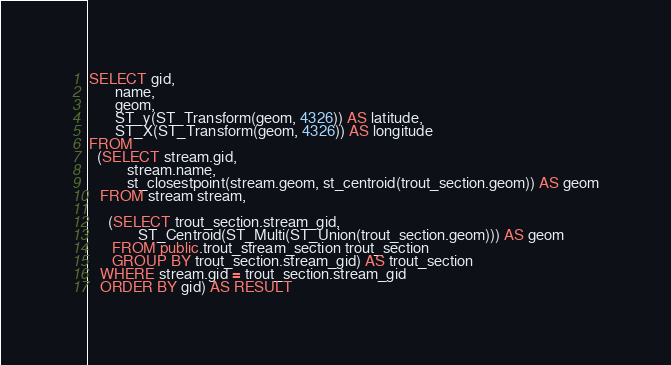Convert code to text. <code><loc_0><loc_0><loc_500><loc_500><_SQL_>SELECT gid,
       name,
       geom,
       ST_y(ST_Transform(geom, 4326)) AS latitude,
       ST_X(ST_Transform(geom, 4326)) AS longitude
FROM
  (SELECT stream.gid,
          stream.name,
          st_closestpoint(stream.geom, st_centroid(trout_section.geom)) AS geom
   FROM stream stream,

     (SELECT trout_section.stream_gid,
             ST_Centroid(ST_Multi(ST_Union(trout_section.geom))) AS geom
      FROM public.trout_stream_section trout_section
      GROUP BY trout_section.stream_gid) AS trout_section
   WHERE stream.gid = trout_section.stream_gid
   ORDER BY gid) AS RESULT</code> 